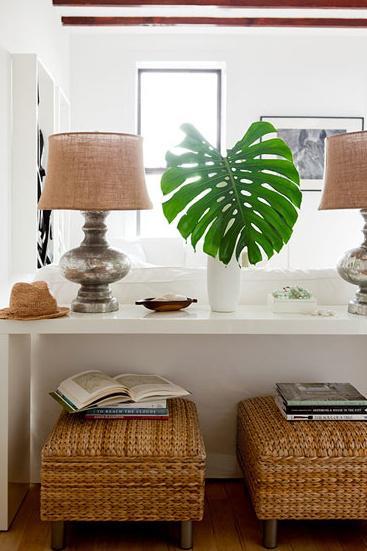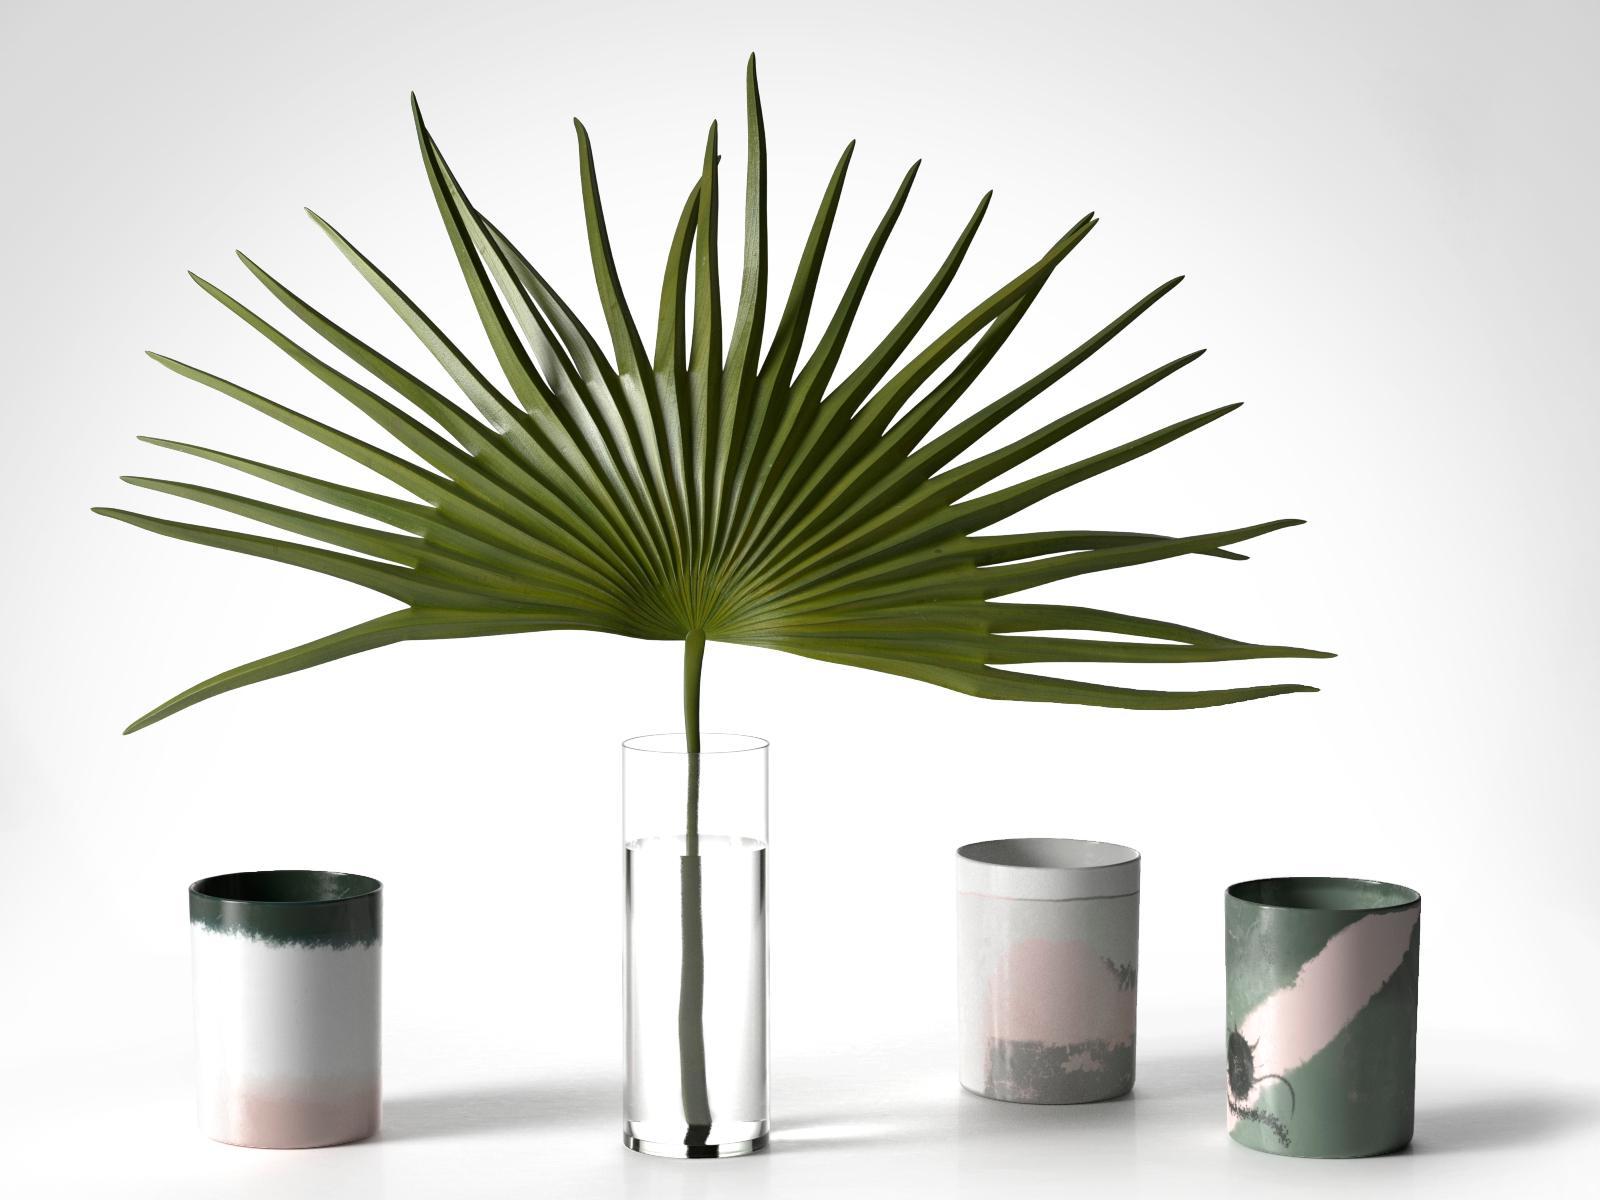The first image is the image on the left, the second image is the image on the right. Considering the images on both sides, is "The right image features a palm frond in a clear cylindrical vase flanked by objects with matching shapes." valid? Answer yes or no. Yes. The first image is the image on the left, the second image is the image on the right. Considering the images on both sides, is "The left and right image contains the same number of palm leaves." valid? Answer yes or no. Yes. 